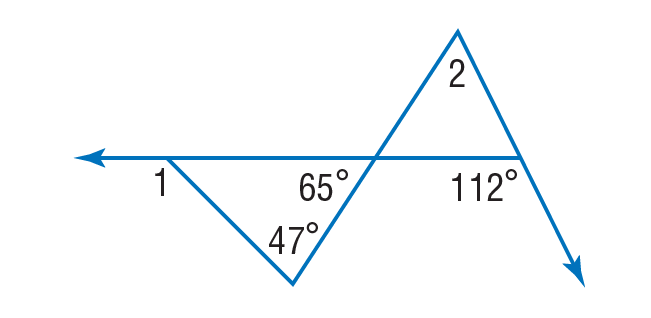Answer the mathemtical geometry problem and directly provide the correct option letter.
Question: Find \angle 2.
Choices: A: 47 B: 65 C: 112 D: 177 A 